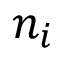Convert formula to latex. <formula><loc_0><loc_0><loc_500><loc_500>n _ { i }</formula> 